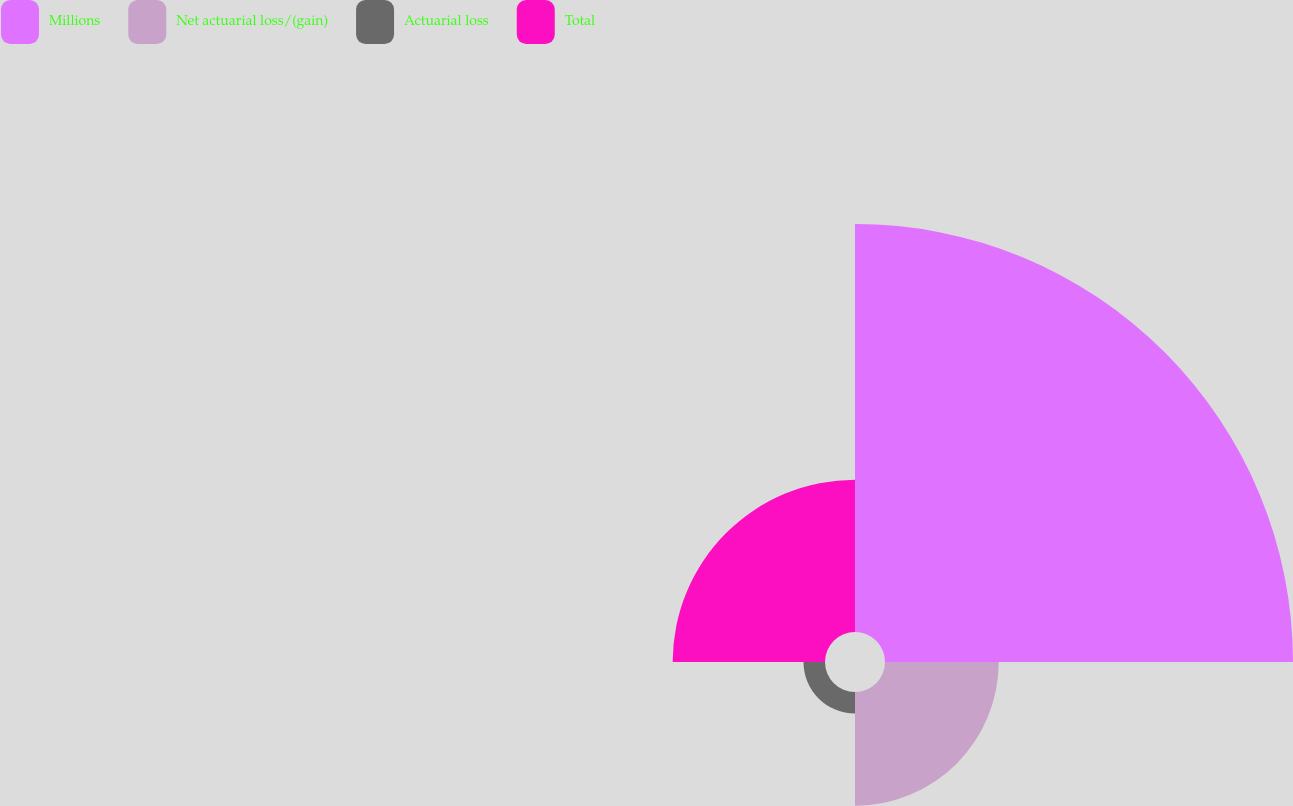Convert chart to OTSL. <chart><loc_0><loc_0><loc_500><loc_500><pie_chart><fcel>Millions<fcel>Net actuarial loss/(gain)<fcel>Actuarial loss<fcel>Total<nl><fcel>58.66%<fcel>16.35%<fcel>3.09%<fcel>21.9%<nl></chart> 